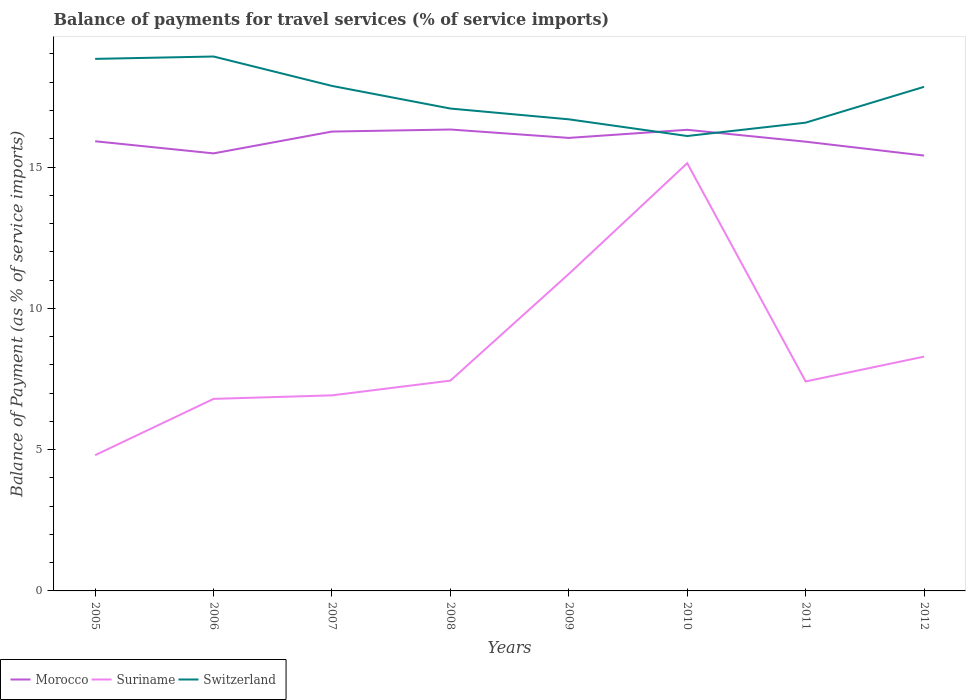Does the line corresponding to Suriname intersect with the line corresponding to Morocco?
Provide a succinct answer. No. Across all years, what is the maximum balance of payments for travel services in Switzerland?
Your answer should be very brief. 16.1. In which year was the balance of payments for travel services in Switzerland maximum?
Ensure brevity in your answer.  2010. What is the total balance of payments for travel services in Suriname in the graph?
Keep it short and to the point. -0.65. What is the difference between the highest and the second highest balance of payments for travel services in Suriname?
Offer a very short reply. 10.33. What is the difference between the highest and the lowest balance of payments for travel services in Morocco?
Your answer should be compact. 4. Is the balance of payments for travel services in Morocco strictly greater than the balance of payments for travel services in Switzerland over the years?
Your answer should be very brief. No. How many years are there in the graph?
Make the answer very short. 8. Are the values on the major ticks of Y-axis written in scientific E-notation?
Your answer should be very brief. No. Does the graph contain any zero values?
Provide a short and direct response. No. Does the graph contain grids?
Offer a very short reply. No. Where does the legend appear in the graph?
Your response must be concise. Bottom left. How many legend labels are there?
Your answer should be very brief. 3. How are the legend labels stacked?
Your response must be concise. Horizontal. What is the title of the graph?
Offer a terse response. Balance of payments for travel services (% of service imports). Does "St. Vincent and the Grenadines" appear as one of the legend labels in the graph?
Keep it short and to the point. No. What is the label or title of the Y-axis?
Offer a terse response. Balance of Payment (as % of service imports). What is the Balance of Payment (as % of service imports) in Morocco in 2005?
Your answer should be very brief. 15.91. What is the Balance of Payment (as % of service imports) of Suriname in 2005?
Offer a very short reply. 4.8. What is the Balance of Payment (as % of service imports) of Switzerland in 2005?
Your answer should be compact. 18.83. What is the Balance of Payment (as % of service imports) in Morocco in 2006?
Keep it short and to the point. 15.48. What is the Balance of Payment (as % of service imports) in Suriname in 2006?
Ensure brevity in your answer.  6.8. What is the Balance of Payment (as % of service imports) of Switzerland in 2006?
Offer a terse response. 18.91. What is the Balance of Payment (as % of service imports) in Morocco in 2007?
Provide a succinct answer. 16.25. What is the Balance of Payment (as % of service imports) in Suriname in 2007?
Offer a very short reply. 6.92. What is the Balance of Payment (as % of service imports) of Switzerland in 2007?
Ensure brevity in your answer.  17.87. What is the Balance of Payment (as % of service imports) of Morocco in 2008?
Keep it short and to the point. 16.33. What is the Balance of Payment (as % of service imports) in Suriname in 2008?
Keep it short and to the point. 7.44. What is the Balance of Payment (as % of service imports) in Switzerland in 2008?
Your answer should be compact. 17.07. What is the Balance of Payment (as % of service imports) in Morocco in 2009?
Give a very brief answer. 16.03. What is the Balance of Payment (as % of service imports) of Suriname in 2009?
Keep it short and to the point. 11.22. What is the Balance of Payment (as % of service imports) in Switzerland in 2009?
Your answer should be compact. 16.69. What is the Balance of Payment (as % of service imports) of Morocco in 2010?
Your answer should be very brief. 16.32. What is the Balance of Payment (as % of service imports) in Suriname in 2010?
Offer a very short reply. 15.14. What is the Balance of Payment (as % of service imports) of Switzerland in 2010?
Ensure brevity in your answer.  16.1. What is the Balance of Payment (as % of service imports) of Morocco in 2011?
Your response must be concise. 15.9. What is the Balance of Payment (as % of service imports) of Suriname in 2011?
Offer a terse response. 7.41. What is the Balance of Payment (as % of service imports) of Switzerland in 2011?
Provide a succinct answer. 16.57. What is the Balance of Payment (as % of service imports) of Morocco in 2012?
Your answer should be compact. 15.41. What is the Balance of Payment (as % of service imports) in Suriname in 2012?
Keep it short and to the point. 8.29. What is the Balance of Payment (as % of service imports) of Switzerland in 2012?
Give a very brief answer. 17.84. Across all years, what is the maximum Balance of Payment (as % of service imports) in Morocco?
Your response must be concise. 16.33. Across all years, what is the maximum Balance of Payment (as % of service imports) in Suriname?
Your answer should be very brief. 15.14. Across all years, what is the maximum Balance of Payment (as % of service imports) of Switzerland?
Ensure brevity in your answer.  18.91. Across all years, what is the minimum Balance of Payment (as % of service imports) in Morocco?
Make the answer very short. 15.41. Across all years, what is the minimum Balance of Payment (as % of service imports) of Suriname?
Your response must be concise. 4.8. Across all years, what is the minimum Balance of Payment (as % of service imports) of Switzerland?
Your answer should be compact. 16.1. What is the total Balance of Payment (as % of service imports) of Morocco in the graph?
Provide a short and direct response. 127.63. What is the total Balance of Payment (as % of service imports) in Suriname in the graph?
Provide a short and direct response. 68.02. What is the total Balance of Payment (as % of service imports) in Switzerland in the graph?
Make the answer very short. 139.87. What is the difference between the Balance of Payment (as % of service imports) in Morocco in 2005 and that in 2006?
Provide a succinct answer. 0.43. What is the difference between the Balance of Payment (as % of service imports) in Suriname in 2005 and that in 2006?
Your answer should be compact. -1.99. What is the difference between the Balance of Payment (as % of service imports) in Switzerland in 2005 and that in 2006?
Offer a terse response. -0.08. What is the difference between the Balance of Payment (as % of service imports) of Morocco in 2005 and that in 2007?
Your answer should be very brief. -0.34. What is the difference between the Balance of Payment (as % of service imports) of Suriname in 2005 and that in 2007?
Provide a succinct answer. -2.12. What is the difference between the Balance of Payment (as % of service imports) of Switzerland in 2005 and that in 2007?
Keep it short and to the point. 0.96. What is the difference between the Balance of Payment (as % of service imports) of Morocco in 2005 and that in 2008?
Give a very brief answer. -0.42. What is the difference between the Balance of Payment (as % of service imports) in Suriname in 2005 and that in 2008?
Provide a short and direct response. -2.64. What is the difference between the Balance of Payment (as % of service imports) of Switzerland in 2005 and that in 2008?
Keep it short and to the point. 1.76. What is the difference between the Balance of Payment (as % of service imports) in Morocco in 2005 and that in 2009?
Keep it short and to the point. -0.12. What is the difference between the Balance of Payment (as % of service imports) in Suriname in 2005 and that in 2009?
Your answer should be compact. -6.41. What is the difference between the Balance of Payment (as % of service imports) in Switzerland in 2005 and that in 2009?
Offer a very short reply. 2.14. What is the difference between the Balance of Payment (as % of service imports) of Morocco in 2005 and that in 2010?
Your answer should be compact. -0.41. What is the difference between the Balance of Payment (as % of service imports) in Suriname in 2005 and that in 2010?
Ensure brevity in your answer.  -10.33. What is the difference between the Balance of Payment (as % of service imports) of Switzerland in 2005 and that in 2010?
Keep it short and to the point. 2.73. What is the difference between the Balance of Payment (as % of service imports) in Morocco in 2005 and that in 2011?
Provide a succinct answer. 0.01. What is the difference between the Balance of Payment (as % of service imports) of Suriname in 2005 and that in 2011?
Give a very brief answer. -2.61. What is the difference between the Balance of Payment (as % of service imports) of Switzerland in 2005 and that in 2011?
Ensure brevity in your answer.  2.26. What is the difference between the Balance of Payment (as % of service imports) of Morocco in 2005 and that in 2012?
Your answer should be compact. 0.51. What is the difference between the Balance of Payment (as % of service imports) in Suriname in 2005 and that in 2012?
Offer a very short reply. -3.49. What is the difference between the Balance of Payment (as % of service imports) of Morocco in 2006 and that in 2007?
Give a very brief answer. -0.77. What is the difference between the Balance of Payment (as % of service imports) of Suriname in 2006 and that in 2007?
Your answer should be very brief. -0.12. What is the difference between the Balance of Payment (as % of service imports) of Switzerland in 2006 and that in 2007?
Your answer should be compact. 1.04. What is the difference between the Balance of Payment (as % of service imports) of Morocco in 2006 and that in 2008?
Make the answer very short. -0.84. What is the difference between the Balance of Payment (as % of service imports) of Suriname in 2006 and that in 2008?
Ensure brevity in your answer.  -0.65. What is the difference between the Balance of Payment (as % of service imports) of Switzerland in 2006 and that in 2008?
Your answer should be compact. 1.84. What is the difference between the Balance of Payment (as % of service imports) of Morocco in 2006 and that in 2009?
Offer a very short reply. -0.55. What is the difference between the Balance of Payment (as % of service imports) in Suriname in 2006 and that in 2009?
Give a very brief answer. -4.42. What is the difference between the Balance of Payment (as % of service imports) in Switzerland in 2006 and that in 2009?
Offer a very short reply. 2.22. What is the difference between the Balance of Payment (as % of service imports) in Morocco in 2006 and that in 2010?
Offer a very short reply. -0.83. What is the difference between the Balance of Payment (as % of service imports) in Suriname in 2006 and that in 2010?
Make the answer very short. -8.34. What is the difference between the Balance of Payment (as % of service imports) of Switzerland in 2006 and that in 2010?
Ensure brevity in your answer.  2.81. What is the difference between the Balance of Payment (as % of service imports) of Morocco in 2006 and that in 2011?
Offer a very short reply. -0.41. What is the difference between the Balance of Payment (as % of service imports) in Suriname in 2006 and that in 2011?
Ensure brevity in your answer.  -0.62. What is the difference between the Balance of Payment (as % of service imports) of Switzerland in 2006 and that in 2011?
Offer a very short reply. 2.34. What is the difference between the Balance of Payment (as % of service imports) of Morocco in 2006 and that in 2012?
Keep it short and to the point. 0.08. What is the difference between the Balance of Payment (as % of service imports) in Suriname in 2006 and that in 2012?
Provide a succinct answer. -1.5. What is the difference between the Balance of Payment (as % of service imports) of Switzerland in 2006 and that in 2012?
Offer a terse response. 1.07. What is the difference between the Balance of Payment (as % of service imports) in Morocco in 2007 and that in 2008?
Offer a terse response. -0.07. What is the difference between the Balance of Payment (as % of service imports) of Suriname in 2007 and that in 2008?
Provide a succinct answer. -0.52. What is the difference between the Balance of Payment (as % of service imports) of Switzerland in 2007 and that in 2008?
Your answer should be compact. 0.8. What is the difference between the Balance of Payment (as % of service imports) of Morocco in 2007 and that in 2009?
Provide a succinct answer. 0.22. What is the difference between the Balance of Payment (as % of service imports) in Suriname in 2007 and that in 2009?
Give a very brief answer. -4.3. What is the difference between the Balance of Payment (as % of service imports) in Switzerland in 2007 and that in 2009?
Provide a succinct answer. 1.18. What is the difference between the Balance of Payment (as % of service imports) of Morocco in 2007 and that in 2010?
Your answer should be compact. -0.06. What is the difference between the Balance of Payment (as % of service imports) in Suriname in 2007 and that in 2010?
Keep it short and to the point. -8.21. What is the difference between the Balance of Payment (as % of service imports) of Switzerland in 2007 and that in 2010?
Ensure brevity in your answer.  1.77. What is the difference between the Balance of Payment (as % of service imports) of Morocco in 2007 and that in 2011?
Make the answer very short. 0.36. What is the difference between the Balance of Payment (as % of service imports) in Suriname in 2007 and that in 2011?
Keep it short and to the point. -0.49. What is the difference between the Balance of Payment (as % of service imports) in Morocco in 2007 and that in 2012?
Keep it short and to the point. 0.85. What is the difference between the Balance of Payment (as % of service imports) in Suriname in 2007 and that in 2012?
Provide a short and direct response. -1.37. What is the difference between the Balance of Payment (as % of service imports) of Switzerland in 2007 and that in 2012?
Ensure brevity in your answer.  0.03. What is the difference between the Balance of Payment (as % of service imports) of Morocco in 2008 and that in 2009?
Provide a succinct answer. 0.3. What is the difference between the Balance of Payment (as % of service imports) of Suriname in 2008 and that in 2009?
Provide a succinct answer. -3.78. What is the difference between the Balance of Payment (as % of service imports) in Switzerland in 2008 and that in 2009?
Offer a very short reply. 0.38. What is the difference between the Balance of Payment (as % of service imports) in Morocco in 2008 and that in 2010?
Make the answer very short. 0.01. What is the difference between the Balance of Payment (as % of service imports) in Suriname in 2008 and that in 2010?
Keep it short and to the point. -7.69. What is the difference between the Balance of Payment (as % of service imports) of Switzerland in 2008 and that in 2010?
Make the answer very short. 0.97. What is the difference between the Balance of Payment (as % of service imports) of Morocco in 2008 and that in 2011?
Give a very brief answer. 0.43. What is the difference between the Balance of Payment (as % of service imports) in Suriname in 2008 and that in 2011?
Provide a short and direct response. 0.03. What is the difference between the Balance of Payment (as % of service imports) in Switzerland in 2008 and that in 2011?
Provide a short and direct response. 0.5. What is the difference between the Balance of Payment (as % of service imports) of Morocco in 2008 and that in 2012?
Provide a succinct answer. 0.92. What is the difference between the Balance of Payment (as % of service imports) of Suriname in 2008 and that in 2012?
Offer a terse response. -0.85. What is the difference between the Balance of Payment (as % of service imports) of Switzerland in 2008 and that in 2012?
Provide a succinct answer. -0.77. What is the difference between the Balance of Payment (as % of service imports) in Morocco in 2009 and that in 2010?
Provide a succinct answer. -0.29. What is the difference between the Balance of Payment (as % of service imports) of Suriname in 2009 and that in 2010?
Provide a short and direct response. -3.92. What is the difference between the Balance of Payment (as % of service imports) of Switzerland in 2009 and that in 2010?
Your answer should be very brief. 0.59. What is the difference between the Balance of Payment (as % of service imports) in Morocco in 2009 and that in 2011?
Give a very brief answer. 0.13. What is the difference between the Balance of Payment (as % of service imports) of Suriname in 2009 and that in 2011?
Your response must be concise. 3.8. What is the difference between the Balance of Payment (as % of service imports) in Switzerland in 2009 and that in 2011?
Offer a very short reply. 0.12. What is the difference between the Balance of Payment (as % of service imports) in Morocco in 2009 and that in 2012?
Your answer should be very brief. 0.62. What is the difference between the Balance of Payment (as % of service imports) of Suriname in 2009 and that in 2012?
Ensure brevity in your answer.  2.93. What is the difference between the Balance of Payment (as % of service imports) of Switzerland in 2009 and that in 2012?
Make the answer very short. -1.15. What is the difference between the Balance of Payment (as % of service imports) of Morocco in 2010 and that in 2011?
Provide a short and direct response. 0.42. What is the difference between the Balance of Payment (as % of service imports) of Suriname in 2010 and that in 2011?
Provide a succinct answer. 7.72. What is the difference between the Balance of Payment (as % of service imports) in Switzerland in 2010 and that in 2011?
Make the answer very short. -0.47. What is the difference between the Balance of Payment (as % of service imports) in Morocco in 2010 and that in 2012?
Provide a short and direct response. 0.91. What is the difference between the Balance of Payment (as % of service imports) of Suriname in 2010 and that in 2012?
Your response must be concise. 6.84. What is the difference between the Balance of Payment (as % of service imports) of Switzerland in 2010 and that in 2012?
Your answer should be very brief. -1.74. What is the difference between the Balance of Payment (as % of service imports) in Morocco in 2011 and that in 2012?
Provide a succinct answer. 0.49. What is the difference between the Balance of Payment (as % of service imports) of Suriname in 2011 and that in 2012?
Your answer should be very brief. -0.88. What is the difference between the Balance of Payment (as % of service imports) in Switzerland in 2011 and that in 2012?
Ensure brevity in your answer.  -1.27. What is the difference between the Balance of Payment (as % of service imports) in Morocco in 2005 and the Balance of Payment (as % of service imports) in Suriname in 2006?
Provide a short and direct response. 9.12. What is the difference between the Balance of Payment (as % of service imports) of Morocco in 2005 and the Balance of Payment (as % of service imports) of Switzerland in 2006?
Keep it short and to the point. -3. What is the difference between the Balance of Payment (as % of service imports) of Suriname in 2005 and the Balance of Payment (as % of service imports) of Switzerland in 2006?
Keep it short and to the point. -14.11. What is the difference between the Balance of Payment (as % of service imports) of Morocco in 2005 and the Balance of Payment (as % of service imports) of Suriname in 2007?
Offer a terse response. 8.99. What is the difference between the Balance of Payment (as % of service imports) in Morocco in 2005 and the Balance of Payment (as % of service imports) in Switzerland in 2007?
Offer a terse response. -1.96. What is the difference between the Balance of Payment (as % of service imports) of Suriname in 2005 and the Balance of Payment (as % of service imports) of Switzerland in 2007?
Make the answer very short. -13.07. What is the difference between the Balance of Payment (as % of service imports) of Morocco in 2005 and the Balance of Payment (as % of service imports) of Suriname in 2008?
Provide a short and direct response. 8.47. What is the difference between the Balance of Payment (as % of service imports) in Morocco in 2005 and the Balance of Payment (as % of service imports) in Switzerland in 2008?
Your answer should be compact. -1.16. What is the difference between the Balance of Payment (as % of service imports) in Suriname in 2005 and the Balance of Payment (as % of service imports) in Switzerland in 2008?
Offer a very short reply. -12.27. What is the difference between the Balance of Payment (as % of service imports) in Morocco in 2005 and the Balance of Payment (as % of service imports) in Suriname in 2009?
Offer a terse response. 4.7. What is the difference between the Balance of Payment (as % of service imports) in Morocco in 2005 and the Balance of Payment (as % of service imports) in Switzerland in 2009?
Ensure brevity in your answer.  -0.78. What is the difference between the Balance of Payment (as % of service imports) in Suriname in 2005 and the Balance of Payment (as % of service imports) in Switzerland in 2009?
Offer a very short reply. -11.88. What is the difference between the Balance of Payment (as % of service imports) of Morocco in 2005 and the Balance of Payment (as % of service imports) of Suriname in 2010?
Offer a very short reply. 0.78. What is the difference between the Balance of Payment (as % of service imports) of Morocco in 2005 and the Balance of Payment (as % of service imports) of Switzerland in 2010?
Your answer should be compact. -0.19. What is the difference between the Balance of Payment (as % of service imports) of Suriname in 2005 and the Balance of Payment (as % of service imports) of Switzerland in 2010?
Your response must be concise. -11.29. What is the difference between the Balance of Payment (as % of service imports) in Morocco in 2005 and the Balance of Payment (as % of service imports) in Suriname in 2011?
Provide a short and direct response. 8.5. What is the difference between the Balance of Payment (as % of service imports) in Morocco in 2005 and the Balance of Payment (as % of service imports) in Switzerland in 2011?
Your answer should be very brief. -0.66. What is the difference between the Balance of Payment (as % of service imports) of Suriname in 2005 and the Balance of Payment (as % of service imports) of Switzerland in 2011?
Your answer should be compact. -11.77. What is the difference between the Balance of Payment (as % of service imports) of Morocco in 2005 and the Balance of Payment (as % of service imports) of Suriname in 2012?
Offer a very short reply. 7.62. What is the difference between the Balance of Payment (as % of service imports) in Morocco in 2005 and the Balance of Payment (as % of service imports) in Switzerland in 2012?
Offer a very short reply. -1.93. What is the difference between the Balance of Payment (as % of service imports) of Suriname in 2005 and the Balance of Payment (as % of service imports) of Switzerland in 2012?
Offer a terse response. -13.03. What is the difference between the Balance of Payment (as % of service imports) of Morocco in 2006 and the Balance of Payment (as % of service imports) of Suriname in 2007?
Your answer should be compact. 8.56. What is the difference between the Balance of Payment (as % of service imports) in Morocco in 2006 and the Balance of Payment (as % of service imports) in Switzerland in 2007?
Your answer should be compact. -2.39. What is the difference between the Balance of Payment (as % of service imports) in Suriname in 2006 and the Balance of Payment (as % of service imports) in Switzerland in 2007?
Make the answer very short. -11.07. What is the difference between the Balance of Payment (as % of service imports) of Morocco in 2006 and the Balance of Payment (as % of service imports) of Suriname in 2008?
Offer a terse response. 8.04. What is the difference between the Balance of Payment (as % of service imports) of Morocco in 2006 and the Balance of Payment (as % of service imports) of Switzerland in 2008?
Make the answer very short. -1.59. What is the difference between the Balance of Payment (as % of service imports) in Suriname in 2006 and the Balance of Payment (as % of service imports) in Switzerland in 2008?
Ensure brevity in your answer.  -10.27. What is the difference between the Balance of Payment (as % of service imports) of Morocco in 2006 and the Balance of Payment (as % of service imports) of Suriname in 2009?
Your response must be concise. 4.27. What is the difference between the Balance of Payment (as % of service imports) in Morocco in 2006 and the Balance of Payment (as % of service imports) in Switzerland in 2009?
Offer a terse response. -1.21. What is the difference between the Balance of Payment (as % of service imports) of Suriname in 2006 and the Balance of Payment (as % of service imports) of Switzerland in 2009?
Give a very brief answer. -9.89. What is the difference between the Balance of Payment (as % of service imports) of Morocco in 2006 and the Balance of Payment (as % of service imports) of Suriname in 2010?
Offer a terse response. 0.35. What is the difference between the Balance of Payment (as % of service imports) in Morocco in 2006 and the Balance of Payment (as % of service imports) in Switzerland in 2010?
Give a very brief answer. -0.61. What is the difference between the Balance of Payment (as % of service imports) in Suriname in 2006 and the Balance of Payment (as % of service imports) in Switzerland in 2010?
Provide a succinct answer. -9.3. What is the difference between the Balance of Payment (as % of service imports) in Morocco in 2006 and the Balance of Payment (as % of service imports) in Suriname in 2011?
Keep it short and to the point. 8.07. What is the difference between the Balance of Payment (as % of service imports) of Morocco in 2006 and the Balance of Payment (as % of service imports) of Switzerland in 2011?
Provide a succinct answer. -1.09. What is the difference between the Balance of Payment (as % of service imports) in Suriname in 2006 and the Balance of Payment (as % of service imports) in Switzerland in 2011?
Keep it short and to the point. -9.77. What is the difference between the Balance of Payment (as % of service imports) of Morocco in 2006 and the Balance of Payment (as % of service imports) of Suriname in 2012?
Provide a short and direct response. 7.19. What is the difference between the Balance of Payment (as % of service imports) of Morocco in 2006 and the Balance of Payment (as % of service imports) of Switzerland in 2012?
Ensure brevity in your answer.  -2.36. What is the difference between the Balance of Payment (as % of service imports) of Suriname in 2006 and the Balance of Payment (as % of service imports) of Switzerland in 2012?
Offer a very short reply. -11.04. What is the difference between the Balance of Payment (as % of service imports) of Morocco in 2007 and the Balance of Payment (as % of service imports) of Suriname in 2008?
Give a very brief answer. 8.81. What is the difference between the Balance of Payment (as % of service imports) in Morocco in 2007 and the Balance of Payment (as % of service imports) in Switzerland in 2008?
Your answer should be compact. -0.81. What is the difference between the Balance of Payment (as % of service imports) in Suriname in 2007 and the Balance of Payment (as % of service imports) in Switzerland in 2008?
Your response must be concise. -10.15. What is the difference between the Balance of Payment (as % of service imports) in Morocco in 2007 and the Balance of Payment (as % of service imports) in Suriname in 2009?
Your answer should be compact. 5.04. What is the difference between the Balance of Payment (as % of service imports) in Morocco in 2007 and the Balance of Payment (as % of service imports) in Switzerland in 2009?
Offer a terse response. -0.43. What is the difference between the Balance of Payment (as % of service imports) in Suriname in 2007 and the Balance of Payment (as % of service imports) in Switzerland in 2009?
Provide a succinct answer. -9.77. What is the difference between the Balance of Payment (as % of service imports) in Morocco in 2007 and the Balance of Payment (as % of service imports) in Suriname in 2010?
Provide a short and direct response. 1.12. What is the difference between the Balance of Payment (as % of service imports) of Morocco in 2007 and the Balance of Payment (as % of service imports) of Switzerland in 2010?
Give a very brief answer. 0.16. What is the difference between the Balance of Payment (as % of service imports) in Suriname in 2007 and the Balance of Payment (as % of service imports) in Switzerland in 2010?
Ensure brevity in your answer.  -9.18. What is the difference between the Balance of Payment (as % of service imports) of Morocco in 2007 and the Balance of Payment (as % of service imports) of Suriname in 2011?
Offer a very short reply. 8.84. What is the difference between the Balance of Payment (as % of service imports) in Morocco in 2007 and the Balance of Payment (as % of service imports) in Switzerland in 2011?
Your answer should be very brief. -0.32. What is the difference between the Balance of Payment (as % of service imports) in Suriname in 2007 and the Balance of Payment (as % of service imports) in Switzerland in 2011?
Provide a succinct answer. -9.65. What is the difference between the Balance of Payment (as % of service imports) in Morocco in 2007 and the Balance of Payment (as % of service imports) in Suriname in 2012?
Your answer should be compact. 7.96. What is the difference between the Balance of Payment (as % of service imports) in Morocco in 2007 and the Balance of Payment (as % of service imports) in Switzerland in 2012?
Make the answer very short. -1.58. What is the difference between the Balance of Payment (as % of service imports) of Suriname in 2007 and the Balance of Payment (as % of service imports) of Switzerland in 2012?
Your answer should be very brief. -10.92. What is the difference between the Balance of Payment (as % of service imports) in Morocco in 2008 and the Balance of Payment (as % of service imports) in Suriname in 2009?
Make the answer very short. 5.11. What is the difference between the Balance of Payment (as % of service imports) of Morocco in 2008 and the Balance of Payment (as % of service imports) of Switzerland in 2009?
Ensure brevity in your answer.  -0.36. What is the difference between the Balance of Payment (as % of service imports) of Suriname in 2008 and the Balance of Payment (as % of service imports) of Switzerland in 2009?
Offer a terse response. -9.25. What is the difference between the Balance of Payment (as % of service imports) of Morocco in 2008 and the Balance of Payment (as % of service imports) of Suriname in 2010?
Your response must be concise. 1.19. What is the difference between the Balance of Payment (as % of service imports) of Morocco in 2008 and the Balance of Payment (as % of service imports) of Switzerland in 2010?
Your answer should be compact. 0.23. What is the difference between the Balance of Payment (as % of service imports) in Suriname in 2008 and the Balance of Payment (as % of service imports) in Switzerland in 2010?
Offer a very short reply. -8.66. What is the difference between the Balance of Payment (as % of service imports) in Morocco in 2008 and the Balance of Payment (as % of service imports) in Suriname in 2011?
Offer a very short reply. 8.91. What is the difference between the Balance of Payment (as % of service imports) of Morocco in 2008 and the Balance of Payment (as % of service imports) of Switzerland in 2011?
Make the answer very short. -0.24. What is the difference between the Balance of Payment (as % of service imports) in Suriname in 2008 and the Balance of Payment (as % of service imports) in Switzerland in 2011?
Your response must be concise. -9.13. What is the difference between the Balance of Payment (as % of service imports) in Morocco in 2008 and the Balance of Payment (as % of service imports) in Suriname in 2012?
Give a very brief answer. 8.04. What is the difference between the Balance of Payment (as % of service imports) of Morocco in 2008 and the Balance of Payment (as % of service imports) of Switzerland in 2012?
Your answer should be compact. -1.51. What is the difference between the Balance of Payment (as % of service imports) of Suriname in 2008 and the Balance of Payment (as % of service imports) of Switzerland in 2012?
Keep it short and to the point. -10.4. What is the difference between the Balance of Payment (as % of service imports) of Morocco in 2009 and the Balance of Payment (as % of service imports) of Suriname in 2010?
Provide a succinct answer. 0.9. What is the difference between the Balance of Payment (as % of service imports) in Morocco in 2009 and the Balance of Payment (as % of service imports) in Switzerland in 2010?
Offer a very short reply. -0.07. What is the difference between the Balance of Payment (as % of service imports) in Suriname in 2009 and the Balance of Payment (as % of service imports) in Switzerland in 2010?
Your response must be concise. -4.88. What is the difference between the Balance of Payment (as % of service imports) of Morocco in 2009 and the Balance of Payment (as % of service imports) of Suriname in 2011?
Ensure brevity in your answer.  8.62. What is the difference between the Balance of Payment (as % of service imports) of Morocco in 2009 and the Balance of Payment (as % of service imports) of Switzerland in 2011?
Your response must be concise. -0.54. What is the difference between the Balance of Payment (as % of service imports) of Suriname in 2009 and the Balance of Payment (as % of service imports) of Switzerland in 2011?
Offer a terse response. -5.35. What is the difference between the Balance of Payment (as % of service imports) in Morocco in 2009 and the Balance of Payment (as % of service imports) in Suriname in 2012?
Provide a succinct answer. 7.74. What is the difference between the Balance of Payment (as % of service imports) in Morocco in 2009 and the Balance of Payment (as % of service imports) in Switzerland in 2012?
Keep it short and to the point. -1.81. What is the difference between the Balance of Payment (as % of service imports) in Suriname in 2009 and the Balance of Payment (as % of service imports) in Switzerland in 2012?
Provide a short and direct response. -6.62. What is the difference between the Balance of Payment (as % of service imports) in Morocco in 2010 and the Balance of Payment (as % of service imports) in Suriname in 2011?
Offer a terse response. 8.9. What is the difference between the Balance of Payment (as % of service imports) of Morocco in 2010 and the Balance of Payment (as % of service imports) of Switzerland in 2011?
Keep it short and to the point. -0.25. What is the difference between the Balance of Payment (as % of service imports) in Suriname in 2010 and the Balance of Payment (as % of service imports) in Switzerland in 2011?
Make the answer very short. -1.43. What is the difference between the Balance of Payment (as % of service imports) in Morocco in 2010 and the Balance of Payment (as % of service imports) in Suriname in 2012?
Provide a short and direct response. 8.03. What is the difference between the Balance of Payment (as % of service imports) in Morocco in 2010 and the Balance of Payment (as % of service imports) in Switzerland in 2012?
Keep it short and to the point. -1.52. What is the difference between the Balance of Payment (as % of service imports) of Suriname in 2010 and the Balance of Payment (as % of service imports) of Switzerland in 2012?
Offer a terse response. -2.7. What is the difference between the Balance of Payment (as % of service imports) of Morocco in 2011 and the Balance of Payment (as % of service imports) of Suriname in 2012?
Provide a succinct answer. 7.61. What is the difference between the Balance of Payment (as % of service imports) of Morocco in 2011 and the Balance of Payment (as % of service imports) of Switzerland in 2012?
Provide a short and direct response. -1.94. What is the difference between the Balance of Payment (as % of service imports) of Suriname in 2011 and the Balance of Payment (as % of service imports) of Switzerland in 2012?
Your response must be concise. -10.43. What is the average Balance of Payment (as % of service imports) in Morocco per year?
Give a very brief answer. 15.95. What is the average Balance of Payment (as % of service imports) in Suriname per year?
Ensure brevity in your answer.  8.5. What is the average Balance of Payment (as % of service imports) in Switzerland per year?
Offer a terse response. 17.48. In the year 2005, what is the difference between the Balance of Payment (as % of service imports) in Morocco and Balance of Payment (as % of service imports) in Suriname?
Keep it short and to the point. 11.11. In the year 2005, what is the difference between the Balance of Payment (as % of service imports) of Morocco and Balance of Payment (as % of service imports) of Switzerland?
Your answer should be compact. -2.92. In the year 2005, what is the difference between the Balance of Payment (as % of service imports) in Suriname and Balance of Payment (as % of service imports) in Switzerland?
Your answer should be compact. -14.02. In the year 2006, what is the difference between the Balance of Payment (as % of service imports) in Morocco and Balance of Payment (as % of service imports) in Suriname?
Give a very brief answer. 8.69. In the year 2006, what is the difference between the Balance of Payment (as % of service imports) of Morocco and Balance of Payment (as % of service imports) of Switzerland?
Your response must be concise. -3.43. In the year 2006, what is the difference between the Balance of Payment (as % of service imports) of Suriname and Balance of Payment (as % of service imports) of Switzerland?
Your answer should be compact. -12.12. In the year 2007, what is the difference between the Balance of Payment (as % of service imports) of Morocco and Balance of Payment (as % of service imports) of Suriname?
Keep it short and to the point. 9.33. In the year 2007, what is the difference between the Balance of Payment (as % of service imports) of Morocco and Balance of Payment (as % of service imports) of Switzerland?
Give a very brief answer. -1.61. In the year 2007, what is the difference between the Balance of Payment (as % of service imports) in Suriname and Balance of Payment (as % of service imports) in Switzerland?
Your response must be concise. -10.95. In the year 2008, what is the difference between the Balance of Payment (as % of service imports) in Morocco and Balance of Payment (as % of service imports) in Suriname?
Provide a short and direct response. 8.89. In the year 2008, what is the difference between the Balance of Payment (as % of service imports) in Morocco and Balance of Payment (as % of service imports) in Switzerland?
Give a very brief answer. -0.74. In the year 2008, what is the difference between the Balance of Payment (as % of service imports) of Suriname and Balance of Payment (as % of service imports) of Switzerland?
Keep it short and to the point. -9.63. In the year 2009, what is the difference between the Balance of Payment (as % of service imports) of Morocco and Balance of Payment (as % of service imports) of Suriname?
Your response must be concise. 4.81. In the year 2009, what is the difference between the Balance of Payment (as % of service imports) in Morocco and Balance of Payment (as % of service imports) in Switzerland?
Make the answer very short. -0.66. In the year 2009, what is the difference between the Balance of Payment (as % of service imports) in Suriname and Balance of Payment (as % of service imports) in Switzerland?
Your answer should be very brief. -5.47. In the year 2010, what is the difference between the Balance of Payment (as % of service imports) in Morocco and Balance of Payment (as % of service imports) in Suriname?
Keep it short and to the point. 1.18. In the year 2010, what is the difference between the Balance of Payment (as % of service imports) of Morocco and Balance of Payment (as % of service imports) of Switzerland?
Ensure brevity in your answer.  0.22. In the year 2010, what is the difference between the Balance of Payment (as % of service imports) in Suriname and Balance of Payment (as % of service imports) in Switzerland?
Offer a very short reply. -0.96. In the year 2011, what is the difference between the Balance of Payment (as % of service imports) of Morocco and Balance of Payment (as % of service imports) of Suriname?
Ensure brevity in your answer.  8.48. In the year 2011, what is the difference between the Balance of Payment (as % of service imports) of Morocco and Balance of Payment (as % of service imports) of Switzerland?
Keep it short and to the point. -0.67. In the year 2011, what is the difference between the Balance of Payment (as % of service imports) in Suriname and Balance of Payment (as % of service imports) in Switzerland?
Your answer should be very brief. -9.16. In the year 2012, what is the difference between the Balance of Payment (as % of service imports) in Morocco and Balance of Payment (as % of service imports) in Suriname?
Ensure brevity in your answer.  7.11. In the year 2012, what is the difference between the Balance of Payment (as % of service imports) in Morocco and Balance of Payment (as % of service imports) in Switzerland?
Make the answer very short. -2.43. In the year 2012, what is the difference between the Balance of Payment (as % of service imports) of Suriname and Balance of Payment (as % of service imports) of Switzerland?
Provide a succinct answer. -9.55. What is the ratio of the Balance of Payment (as % of service imports) of Morocco in 2005 to that in 2006?
Make the answer very short. 1.03. What is the ratio of the Balance of Payment (as % of service imports) of Suriname in 2005 to that in 2006?
Your response must be concise. 0.71. What is the ratio of the Balance of Payment (as % of service imports) in Morocco in 2005 to that in 2007?
Your answer should be compact. 0.98. What is the ratio of the Balance of Payment (as % of service imports) of Suriname in 2005 to that in 2007?
Offer a very short reply. 0.69. What is the ratio of the Balance of Payment (as % of service imports) in Switzerland in 2005 to that in 2007?
Offer a very short reply. 1.05. What is the ratio of the Balance of Payment (as % of service imports) of Morocco in 2005 to that in 2008?
Your answer should be compact. 0.97. What is the ratio of the Balance of Payment (as % of service imports) in Suriname in 2005 to that in 2008?
Offer a very short reply. 0.65. What is the ratio of the Balance of Payment (as % of service imports) in Switzerland in 2005 to that in 2008?
Your response must be concise. 1.1. What is the ratio of the Balance of Payment (as % of service imports) of Morocco in 2005 to that in 2009?
Your answer should be compact. 0.99. What is the ratio of the Balance of Payment (as % of service imports) in Suriname in 2005 to that in 2009?
Make the answer very short. 0.43. What is the ratio of the Balance of Payment (as % of service imports) of Switzerland in 2005 to that in 2009?
Provide a succinct answer. 1.13. What is the ratio of the Balance of Payment (as % of service imports) of Morocco in 2005 to that in 2010?
Your response must be concise. 0.98. What is the ratio of the Balance of Payment (as % of service imports) of Suriname in 2005 to that in 2010?
Give a very brief answer. 0.32. What is the ratio of the Balance of Payment (as % of service imports) of Switzerland in 2005 to that in 2010?
Provide a short and direct response. 1.17. What is the ratio of the Balance of Payment (as % of service imports) of Morocco in 2005 to that in 2011?
Make the answer very short. 1. What is the ratio of the Balance of Payment (as % of service imports) in Suriname in 2005 to that in 2011?
Offer a terse response. 0.65. What is the ratio of the Balance of Payment (as % of service imports) of Switzerland in 2005 to that in 2011?
Provide a succinct answer. 1.14. What is the ratio of the Balance of Payment (as % of service imports) in Morocco in 2005 to that in 2012?
Provide a succinct answer. 1.03. What is the ratio of the Balance of Payment (as % of service imports) of Suriname in 2005 to that in 2012?
Your response must be concise. 0.58. What is the ratio of the Balance of Payment (as % of service imports) of Switzerland in 2005 to that in 2012?
Keep it short and to the point. 1.06. What is the ratio of the Balance of Payment (as % of service imports) of Morocco in 2006 to that in 2007?
Ensure brevity in your answer.  0.95. What is the ratio of the Balance of Payment (as % of service imports) in Suriname in 2006 to that in 2007?
Your answer should be compact. 0.98. What is the ratio of the Balance of Payment (as % of service imports) of Switzerland in 2006 to that in 2007?
Your answer should be very brief. 1.06. What is the ratio of the Balance of Payment (as % of service imports) of Morocco in 2006 to that in 2008?
Ensure brevity in your answer.  0.95. What is the ratio of the Balance of Payment (as % of service imports) of Suriname in 2006 to that in 2008?
Keep it short and to the point. 0.91. What is the ratio of the Balance of Payment (as % of service imports) in Switzerland in 2006 to that in 2008?
Offer a very short reply. 1.11. What is the ratio of the Balance of Payment (as % of service imports) in Morocco in 2006 to that in 2009?
Your response must be concise. 0.97. What is the ratio of the Balance of Payment (as % of service imports) of Suriname in 2006 to that in 2009?
Keep it short and to the point. 0.61. What is the ratio of the Balance of Payment (as % of service imports) of Switzerland in 2006 to that in 2009?
Your response must be concise. 1.13. What is the ratio of the Balance of Payment (as % of service imports) of Morocco in 2006 to that in 2010?
Provide a short and direct response. 0.95. What is the ratio of the Balance of Payment (as % of service imports) in Suriname in 2006 to that in 2010?
Your answer should be very brief. 0.45. What is the ratio of the Balance of Payment (as % of service imports) of Switzerland in 2006 to that in 2010?
Provide a short and direct response. 1.17. What is the ratio of the Balance of Payment (as % of service imports) of Morocco in 2006 to that in 2011?
Your answer should be compact. 0.97. What is the ratio of the Balance of Payment (as % of service imports) in Suriname in 2006 to that in 2011?
Make the answer very short. 0.92. What is the ratio of the Balance of Payment (as % of service imports) in Switzerland in 2006 to that in 2011?
Keep it short and to the point. 1.14. What is the ratio of the Balance of Payment (as % of service imports) in Morocco in 2006 to that in 2012?
Give a very brief answer. 1. What is the ratio of the Balance of Payment (as % of service imports) in Suriname in 2006 to that in 2012?
Ensure brevity in your answer.  0.82. What is the ratio of the Balance of Payment (as % of service imports) in Switzerland in 2006 to that in 2012?
Offer a very short reply. 1.06. What is the ratio of the Balance of Payment (as % of service imports) in Morocco in 2007 to that in 2008?
Provide a succinct answer. 1. What is the ratio of the Balance of Payment (as % of service imports) in Suriname in 2007 to that in 2008?
Give a very brief answer. 0.93. What is the ratio of the Balance of Payment (as % of service imports) in Switzerland in 2007 to that in 2008?
Give a very brief answer. 1.05. What is the ratio of the Balance of Payment (as % of service imports) in Suriname in 2007 to that in 2009?
Give a very brief answer. 0.62. What is the ratio of the Balance of Payment (as % of service imports) in Switzerland in 2007 to that in 2009?
Offer a very short reply. 1.07. What is the ratio of the Balance of Payment (as % of service imports) of Suriname in 2007 to that in 2010?
Ensure brevity in your answer.  0.46. What is the ratio of the Balance of Payment (as % of service imports) in Switzerland in 2007 to that in 2010?
Make the answer very short. 1.11. What is the ratio of the Balance of Payment (as % of service imports) of Morocco in 2007 to that in 2011?
Offer a terse response. 1.02. What is the ratio of the Balance of Payment (as % of service imports) of Suriname in 2007 to that in 2011?
Your answer should be compact. 0.93. What is the ratio of the Balance of Payment (as % of service imports) of Switzerland in 2007 to that in 2011?
Give a very brief answer. 1.08. What is the ratio of the Balance of Payment (as % of service imports) in Morocco in 2007 to that in 2012?
Your answer should be compact. 1.06. What is the ratio of the Balance of Payment (as % of service imports) of Suriname in 2007 to that in 2012?
Your response must be concise. 0.83. What is the ratio of the Balance of Payment (as % of service imports) of Morocco in 2008 to that in 2009?
Keep it short and to the point. 1.02. What is the ratio of the Balance of Payment (as % of service imports) of Suriname in 2008 to that in 2009?
Your answer should be compact. 0.66. What is the ratio of the Balance of Payment (as % of service imports) of Switzerland in 2008 to that in 2009?
Your answer should be compact. 1.02. What is the ratio of the Balance of Payment (as % of service imports) in Morocco in 2008 to that in 2010?
Your response must be concise. 1. What is the ratio of the Balance of Payment (as % of service imports) in Suriname in 2008 to that in 2010?
Your answer should be very brief. 0.49. What is the ratio of the Balance of Payment (as % of service imports) of Switzerland in 2008 to that in 2010?
Offer a very short reply. 1.06. What is the ratio of the Balance of Payment (as % of service imports) of Morocco in 2008 to that in 2011?
Make the answer very short. 1.03. What is the ratio of the Balance of Payment (as % of service imports) in Suriname in 2008 to that in 2011?
Provide a succinct answer. 1. What is the ratio of the Balance of Payment (as % of service imports) in Switzerland in 2008 to that in 2011?
Offer a terse response. 1.03. What is the ratio of the Balance of Payment (as % of service imports) in Morocco in 2008 to that in 2012?
Offer a terse response. 1.06. What is the ratio of the Balance of Payment (as % of service imports) of Suriname in 2008 to that in 2012?
Your response must be concise. 0.9. What is the ratio of the Balance of Payment (as % of service imports) of Switzerland in 2008 to that in 2012?
Your response must be concise. 0.96. What is the ratio of the Balance of Payment (as % of service imports) of Morocco in 2009 to that in 2010?
Provide a short and direct response. 0.98. What is the ratio of the Balance of Payment (as % of service imports) of Suriname in 2009 to that in 2010?
Give a very brief answer. 0.74. What is the ratio of the Balance of Payment (as % of service imports) of Switzerland in 2009 to that in 2010?
Ensure brevity in your answer.  1.04. What is the ratio of the Balance of Payment (as % of service imports) of Morocco in 2009 to that in 2011?
Offer a very short reply. 1.01. What is the ratio of the Balance of Payment (as % of service imports) of Suriname in 2009 to that in 2011?
Provide a short and direct response. 1.51. What is the ratio of the Balance of Payment (as % of service imports) of Switzerland in 2009 to that in 2011?
Offer a very short reply. 1.01. What is the ratio of the Balance of Payment (as % of service imports) in Morocco in 2009 to that in 2012?
Provide a succinct answer. 1.04. What is the ratio of the Balance of Payment (as % of service imports) in Suriname in 2009 to that in 2012?
Offer a terse response. 1.35. What is the ratio of the Balance of Payment (as % of service imports) in Switzerland in 2009 to that in 2012?
Provide a succinct answer. 0.94. What is the ratio of the Balance of Payment (as % of service imports) of Morocco in 2010 to that in 2011?
Keep it short and to the point. 1.03. What is the ratio of the Balance of Payment (as % of service imports) in Suriname in 2010 to that in 2011?
Give a very brief answer. 2.04. What is the ratio of the Balance of Payment (as % of service imports) of Switzerland in 2010 to that in 2011?
Make the answer very short. 0.97. What is the ratio of the Balance of Payment (as % of service imports) of Morocco in 2010 to that in 2012?
Your answer should be compact. 1.06. What is the ratio of the Balance of Payment (as % of service imports) in Suriname in 2010 to that in 2012?
Offer a terse response. 1.83. What is the ratio of the Balance of Payment (as % of service imports) of Switzerland in 2010 to that in 2012?
Provide a succinct answer. 0.9. What is the ratio of the Balance of Payment (as % of service imports) in Morocco in 2011 to that in 2012?
Keep it short and to the point. 1.03. What is the ratio of the Balance of Payment (as % of service imports) in Suriname in 2011 to that in 2012?
Your response must be concise. 0.89. What is the ratio of the Balance of Payment (as % of service imports) of Switzerland in 2011 to that in 2012?
Your answer should be compact. 0.93. What is the difference between the highest and the second highest Balance of Payment (as % of service imports) in Morocco?
Keep it short and to the point. 0.01. What is the difference between the highest and the second highest Balance of Payment (as % of service imports) in Suriname?
Your response must be concise. 3.92. What is the difference between the highest and the second highest Balance of Payment (as % of service imports) in Switzerland?
Make the answer very short. 0.08. What is the difference between the highest and the lowest Balance of Payment (as % of service imports) in Morocco?
Offer a very short reply. 0.92. What is the difference between the highest and the lowest Balance of Payment (as % of service imports) of Suriname?
Make the answer very short. 10.33. What is the difference between the highest and the lowest Balance of Payment (as % of service imports) in Switzerland?
Your answer should be very brief. 2.81. 